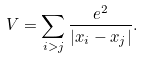Convert formula to latex. <formula><loc_0><loc_0><loc_500><loc_500>V = \sum _ { i > j } \frac { e ^ { 2 } } { | { x } _ { i } - { x } _ { j } | } .</formula> 